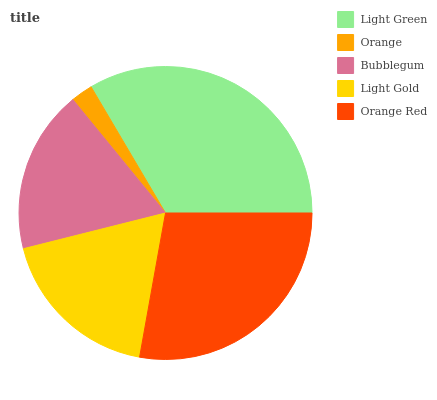Is Orange the minimum?
Answer yes or no. Yes. Is Light Green the maximum?
Answer yes or no. Yes. Is Bubblegum the minimum?
Answer yes or no. No. Is Bubblegum the maximum?
Answer yes or no. No. Is Bubblegum greater than Orange?
Answer yes or no. Yes. Is Orange less than Bubblegum?
Answer yes or no. Yes. Is Orange greater than Bubblegum?
Answer yes or no. No. Is Bubblegum less than Orange?
Answer yes or no. No. Is Light Gold the high median?
Answer yes or no. Yes. Is Light Gold the low median?
Answer yes or no. Yes. Is Bubblegum the high median?
Answer yes or no. No. Is Orange the low median?
Answer yes or no. No. 